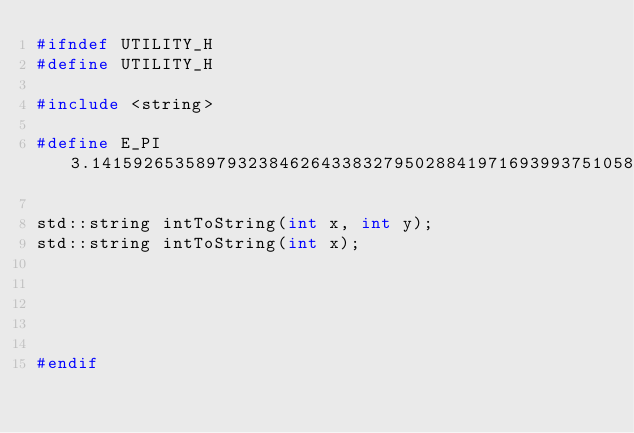Convert code to text. <code><loc_0><loc_0><loc_500><loc_500><_C_>#ifndef UTILITY_H
#define UTILITY_H

#include <string>

#define E_PI 3.1415926535897932384626433832795028841971693993751058209749445923078164062

std::string intToString(int x, int y);
std::string intToString(int x);





#endif</code> 